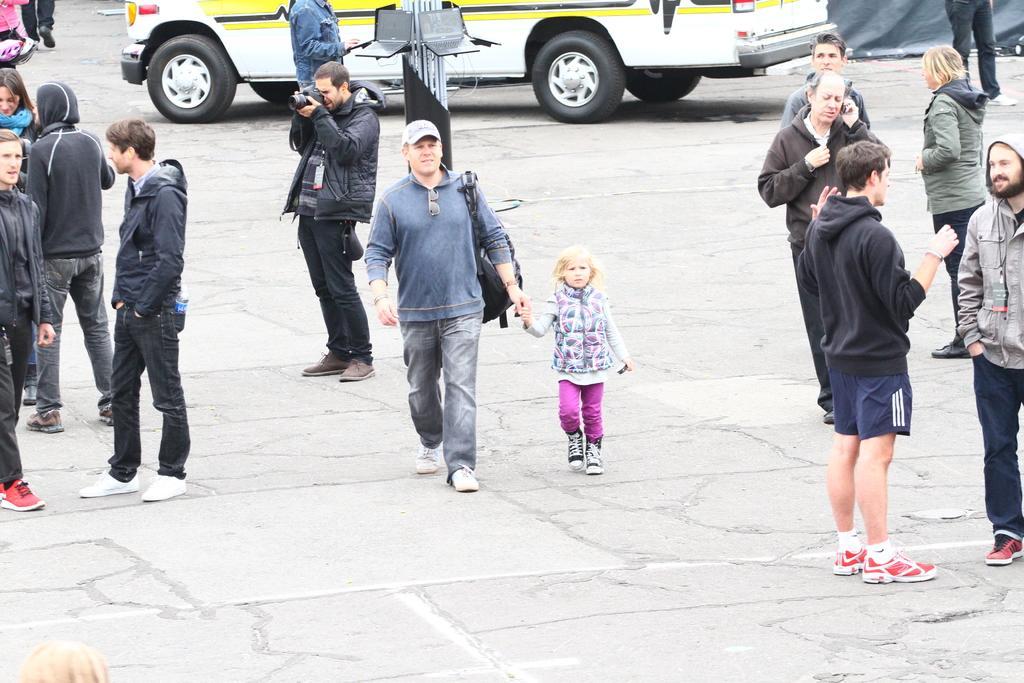In one or two sentences, can you explain what this image depicts? In this image I can see number of person wearing jackets are standing and I can see a person is holding a camera in his hand. In the background I can see a white colored vehicle, a pole and few laptops to the pole and the black colored sheet. 